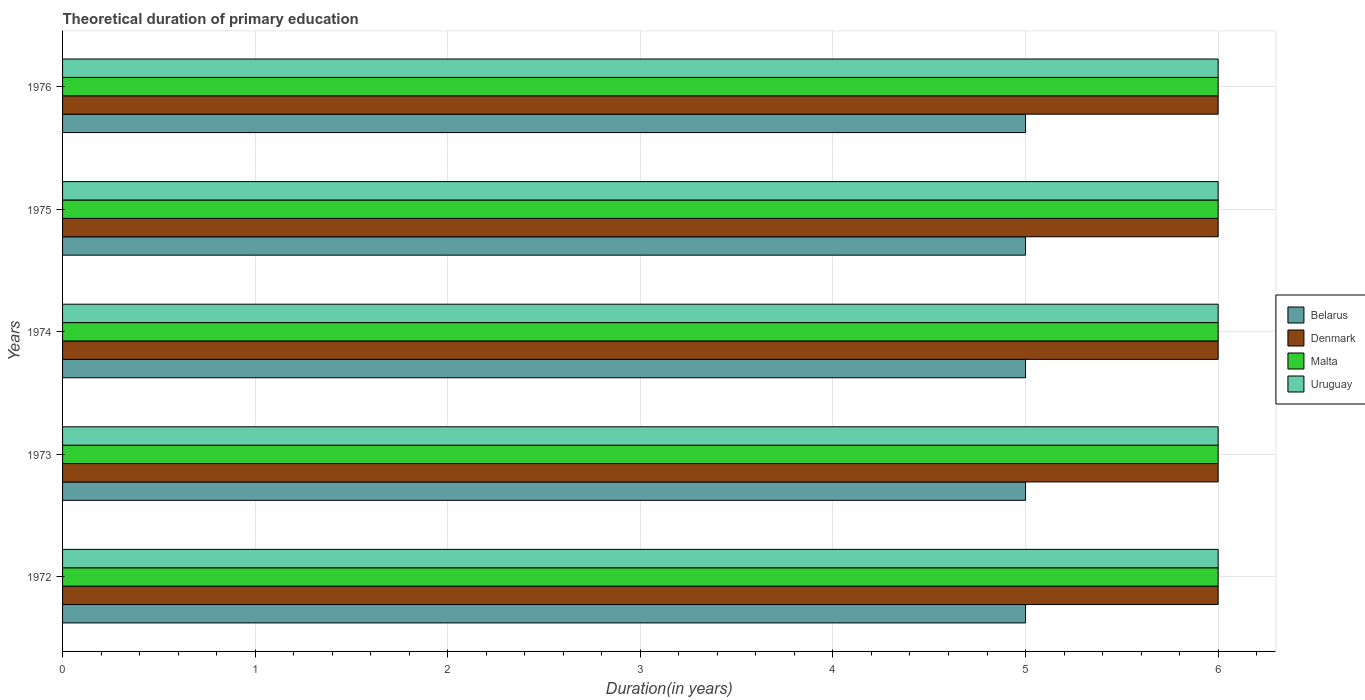How many bars are there on the 5th tick from the bottom?
Your response must be concise. 4. What is the label of the 3rd group of bars from the top?
Provide a short and direct response. 1974. In how many cases, is the number of bars for a given year not equal to the number of legend labels?
Offer a terse response. 0. What is the total theoretical duration of primary education in Belarus in 1975?
Provide a succinct answer. 5. Across all years, what is the minimum total theoretical duration of primary education in Denmark?
Your response must be concise. 6. What is the total total theoretical duration of primary education in Malta in the graph?
Your response must be concise. 30. What is the difference between the total theoretical duration of primary education in Belarus in 1973 and that in 1974?
Your answer should be compact. 0. In the year 1975, what is the difference between the total theoretical duration of primary education in Belarus and total theoretical duration of primary education in Denmark?
Offer a very short reply. -1. In how many years, is the total theoretical duration of primary education in Denmark greater than 2.4 years?
Provide a short and direct response. 5. What is the ratio of the total theoretical duration of primary education in Denmark in 1974 to that in 1975?
Make the answer very short. 1. In how many years, is the total theoretical duration of primary education in Uruguay greater than the average total theoretical duration of primary education in Uruguay taken over all years?
Your answer should be very brief. 0. Is the sum of the total theoretical duration of primary education in Belarus in 1974 and 1976 greater than the maximum total theoretical duration of primary education in Malta across all years?
Ensure brevity in your answer.  Yes. Is it the case that in every year, the sum of the total theoretical duration of primary education in Malta and total theoretical duration of primary education in Uruguay is greater than the sum of total theoretical duration of primary education in Belarus and total theoretical duration of primary education in Denmark?
Provide a succinct answer. No. What does the 1st bar from the top in 1976 represents?
Make the answer very short. Uruguay. What does the 4th bar from the bottom in 1973 represents?
Keep it short and to the point. Uruguay. Is it the case that in every year, the sum of the total theoretical duration of primary education in Uruguay and total theoretical duration of primary education in Belarus is greater than the total theoretical duration of primary education in Denmark?
Give a very brief answer. Yes. How many bars are there?
Keep it short and to the point. 20. How many years are there in the graph?
Keep it short and to the point. 5. What is the difference between two consecutive major ticks on the X-axis?
Offer a very short reply. 1. Does the graph contain any zero values?
Provide a short and direct response. No. Where does the legend appear in the graph?
Give a very brief answer. Center right. What is the title of the graph?
Provide a short and direct response. Theoretical duration of primary education. What is the label or title of the X-axis?
Your answer should be very brief. Duration(in years). What is the label or title of the Y-axis?
Provide a short and direct response. Years. What is the Duration(in years) in Belarus in 1972?
Offer a terse response. 5. What is the Duration(in years) of Malta in 1972?
Offer a very short reply. 6. What is the Duration(in years) of Uruguay in 1972?
Your answer should be very brief. 6. What is the Duration(in years) of Belarus in 1973?
Your response must be concise. 5. What is the Duration(in years) of Denmark in 1973?
Give a very brief answer. 6. What is the Duration(in years) in Malta in 1973?
Give a very brief answer. 6. What is the Duration(in years) of Uruguay in 1973?
Ensure brevity in your answer.  6. What is the Duration(in years) in Belarus in 1974?
Offer a very short reply. 5. What is the Duration(in years) in Denmark in 1974?
Your answer should be very brief. 6. What is the Duration(in years) in Belarus in 1975?
Your response must be concise. 5. What is the Duration(in years) in Malta in 1975?
Offer a very short reply. 6. What is the Duration(in years) in Belarus in 1976?
Offer a terse response. 5. What is the Duration(in years) of Denmark in 1976?
Make the answer very short. 6. What is the Duration(in years) in Malta in 1976?
Ensure brevity in your answer.  6. What is the Duration(in years) of Uruguay in 1976?
Your answer should be compact. 6. Across all years, what is the maximum Duration(in years) in Denmark?
Your answer should be compact. 6. Across all years, what is the maximum Duration(in years) in Malta?
Your answer should be very brief. 6. Across all years, what is the minimum Duration(in years) of Malta?
Your response must be concise. 6. Across all years, what is the minimum Duration(in years) of Uruguay?
Provide a succinct answer. 6. What is the total Duration(in years) of Belarus in the graph?
Provide a short and direct response. 25. What is the total Duration(in years) in Denmark in the graph?
Your answer should be compact. 30. What is the total Duration(in years) of Malta in the graph?
Give a very brief answer. 30. What is the total Duration(in years) in Uruguay in the graph?
Give a very brief answer. 30. What is the difference between the Duration(in years) in Denmark in 1972 and that in 1973?
Provide a short and direct response. 0. What is the difference between the Duration(in years) of Uruguay in 1972 and that in 1973?
Keep it short and to the point. 0. What is the difference between the Duration(in years) of Malta in 1972 and that in 1974?
Your answer should be compact. 0. What is the difference between the Duration(in years) of Malta in 1972 and that in 1975?
Offer a very short reply. 0. What is the difference between the Duration(in years) in Uruguay in 1972 and that in 1975?
Your answer should be very brief. 0. What is the difference between the Duration(in years) in Denmark in 1972 and that in 1976?
Give a very brief answer. 0. What is the difference between the Duration(in years) in Malta in 1972 and that in 1976?
Offer a terse response. 0. What is the difference between the Duration(in years) in Uruguay in 1972 and that in 1976?
Your response must be concise. 0. What is the difference between the Duration(in years) in Belarus in 1973 and that in 1974?
Offer a terse response. 0. What is the difference between the Duration(in years) of Denmark in 1973 and that in 1974?
Keep it short and to the point. 0. What is the difference between the Duration(in years) in Malta in 1973 and that in 1974?
Your answer should be very brief. 0. What is the difference between the Duration(in years) of Belarus in 1973 and that in 1975?
Offer a terse response. 0. What is the difference between the Duration(in years) of Malta in 1973 and that in 1975?
Provide a succinct answer. 0. What is the difference between the Duration(in years) of Uruguay in 1973 and that in 1975?
Make the answer very short. 0. What is the difference between the Duration(in years) of Belarus in 1973 and that in 1976?
Offer a terse response. 0. What is the difference between the Duration(in years) of Denmark in 1973 and that in 1976?
Your response must be concise. 0. What is the difference between the Duration(in years) in Malta in 1973 and that in 1976?
Provide a short and direct response. 0. What is the difference between the Duration(in years) in Uruguay in 1973 and that in 1976?
Keep it short and to the point. 0. What is the difference between the Duration(in years) of Denmark in 1974 and that in 1975?
Offer a very short reply. 0. What is the difference between the Duration(in years) of Uruguay in 1974 and that in 1975?
Offer a terse response. 0. What is the difference between the Duration(in years) of Denmark in 1974 and that in 1976?
Offer a very short reply. 0. What is the difference between the Duration(in years) of Malta in 1974 and that in 1976?
Make the answer very short. 0. What is the difference between the Duration(in years) in Uruguay in 1974 and that in 1976?
Provide a succinct answer. 0. What is the difference between the Duration(in years) in Belarus in 1975 and that in 1976?
Provide a succinct answer. 0. What is the difference between the Duration(in years) in Malta in 1975 and that in 1976?
Offer a terse response. 0. What is the difference between the Duration(in years) in Belarus in 1972 and the Duration(in years) in Uruguay in 1973?
Make the answer very short. -1. What is the difference between the Duration(in years) of Denmark in 1972 and the Duration(in years) of Malta in 1973?
Keep it short and to the point. 0. What is the difference between the Duration(in years) of Belarus in 1972 and the Duration(in years) of Denmark in 1974?
Your answer should be very brief. -1. What is the difference between the Duration(in years) of Belarus in 1972 and the Duration(in years) of Malta in 1974?
Make the answer very short. -1. What is the difference between the Duration(in years) of Belarus in 1972 and the Duration(in years) of Uruguay in 1974?
Your answer should be compact. -1. What is the difference between the Duration(in years) of Denmark in 1972 and the Duration(in years) of Uruguay in 1974?
Give a very brief answer. 0. What is the difference between the Duration(in years) in Belarus in 1972 and the Duration(in years) in Uruguay in 1975?
Keep it short and to the point. -1. What is the difference between the Duration(in years) in Denmark in 1972 and the Duration(in years) in Malta in 1975?
Offer a terse response. 0. What is the difference between the Duration(in years) in Denmark in 1972 and the Duration(in years) in Uruguay in 1975?
Provide a short and direct response. 0. What is the difference between the Duration(in years) in Belarus in 1972 and the Duration(in years) in Malta in 1976?
Offer a very short reply. -1. What is the difference between the Duration(in years) of Belarus in 1972 and the Duration(in years) of Uruguay in 1976?
Keep it short and to the point. -1. What is the difference between the Duration(in years) in Denmark in 1972 and the Duration(in years) in Malta in 1976?
Your answer should be very brief. 0. What is the difference between the Duration(in years) of Denmark in 1972 and the Duration(in years) of Uruguay in 1976?
Ensure brevity in your answer.  0. What is the difference between the Duration(in years) of Malta in 1972 and the Duration(in years) of Uruguay in 1976?
Provide a succinct answer. 0. What is the difference between the Duration(in years) of Belarus in 1973 and the Duration(in years) of Denmark in 1974?
Your answer should be compact. -1. What is the difference between the Duration(in years) of Belarus in 1973 and the Duration(in years) of Malta in 1974?
Your answer should be very brief. -1. What is the difference between the Duration(in years) in Belarus in 1973 and the Duration(in years) in Uruguay in 1974?
Your response must be concise. -1. What is the difference between the Duration(in years) in Denmark in 1973 and the Duration(in years) in Uruguay in 1974?
Provide a short and direct response. 0. What is the difference between the Duration(in years) of Belarus in 1973 and the Duration(in years) of Denmark in 1975?
Your answer should be compact. -1. What is the difference between the Duration(in years) in Belarus in 1973 and the Duration(in years) in Malta in 1975?
Provide a short and direct response. -1. What is the difference between the Duration(in years) in Denmark in 1973 and the Duration(in years) in Malta in 1975?
Give a very brief answer. 0. What is the difference between the Duration(in years) of Denmark in 1973 and the Duration(in years) of Uruguay in 1975?
Ensure brevity in your answer.  0. What is the difference between the Duration(in years) of Malta in 1973 and the Duration(in years) of Uruguay in 1975?
Your response must be concise. 0. What is the difference between the Duration(in years) in Belarus in 1973 and the Duration(in years) in Denmark in 1976?
Offer a very short reply. -1. What is the difference between the Duration(in years) in Denmark in 1973 and the Duration(in years) in Uruguay in 1976?
Offer a very short reply. 0. What is the difference between the Duration(in years) of Malta in 1973 and the Duration(in years) of Uruguay in 1976?
Your answer should be compact. 0. What is the difference between the Duration(in years) in Belarus in 1974 and the Duration(in years) in Malta in 1975?
Give a very brief answer. -1. What is the difference between the Duration(in years) in Belarus in 1974 and the Duration(in years) in Uruguay in 1975?
Provide a succinct answer. -1. What is the difference between the Duration(in years) of Denmark in 1974 and the Duration(in years) of Uruguay in 1975?
Make the answer very short. 0. What is the difference between the Duration(in years) of Belarus in 1974 and the Duration(in years) of Denmark in 1976?
Ensure brevity in your answer.  -1. What is the difference between the Duration(in years) in Belarus in 1974 and the Duration(in years) in Uruguay in 1976?
Offer a very short reply. -1. What is the difference between the Duration(in years) of Denmark in 1974 and the Duration(in years) of Uruguay in 1976?
Make the answer very short. 0. What is the difference between the Duration(in years) of Denmark in 1975 and the Duration(in years) of Malta in 1976?
Ensure brevity in your answer.  0. What is the difference between the Duration(in years) of Denmark in 1975 and the Duration(in years) of Uruguay in 1976?
Your answer should be very brief. 0. What is the difference between the Duration(in years) of Malta in 1975 and the Duration(in years) of Uruguay in 1976?
Give a very brief answer. 0. What is the average Duration(in years) in Belarus per year?
Your answer should be compact. 5. What is the average Duration(in years) of Uruguay per year?
Give a very brief answer. 6. In the year 1972, what is the difference between the Duration(in years) in Belarus and Duration(in years) in Denmark?
Make the answer very short. -1. In the year 1972, what is the difference between the Duration(in years) of Belarus and Duration(in years) of Malta?
Your answer should be compact. -1. In the year 1972, what is the difference between the Duration(in years) of Malta and Duration(in years) of Uruguay?
Keep it short and to the point. 0. In the year 1973, what is the difference between the Duration(in years) of Belarus and Duration(in years) of Denmark?
Make the answer very short. -1. In the year 1973, what is the difference between the Duration(in years) of Denmark and Duration(in years) of Uruguay?
Your answer should be very brief. 0. In the year 1974, what is the difference between the Duration(in years) in Belarus and Duration(in years) in Denmark?
Ensure brevity in your answer.  -1. In the year 1975, what is the difference between the Duration(in years) in Belarus and Duration(in years) in Denmark?
Your answer should be compact. -1. In the year 1975, what is the difference between the Duration(in years) in Belarus and Duration(in years) in Uruguay?
Provide a succinct answer. -1. In the year 1976, what is the difference between the Duration(in years) in Belarus and Duration(in years) in Malta?
Give a very brief answer. -1. In the year 1976, what is the difference between the Duration(in years) in Denmark and Duration(in years) in Malta?
Your answer should be compact. 0. In the year 1976, what is the difference between the Duration(in years) of Malta and Duration(in years) of Uruguay?
Offer a terse response. 0. What is the ratio of the Duration(in years) of Uruguay in 1972 to that in 1973?
Give a very brief answer. 1. What is the ratio of the Duration(in years) of Belarus in 1972 to that in 1974?
Keep it short and to the point. 1. What is the ratio of the Duration(in years) in Denmark in 1972 to that in 1974?
Provide a short and direct response. 1. What is the ratio of the Duration(in years) in Malta in 1972 to that in 1974?
Your response must be concise. 1. What is the ratio of the Duration(in years) of Uruguay in 1972 to that in 1974?
Keep it short and to the point. 1. What is the ratio of the Duration(in years) of Belarus in 1972 to that in 1975?
Provide a short and direct response. 1. What is the ratio of the Duration(in years) in Malta in 1972 to that in 1975?
Offer a terse response. 1. What is the ratio of the Duration(in years) of Belarus in 1972 to that in 1976?
Your answer should be very brief. 1. What is the ratio of the Duration(in years) of Denmark in 1972 to that in 1976?
Keep it short and to the point. 1. What is the ratio of the Duration(in years) in Malta in 1972 to that in 1976?
Offer a very short reply. 1. What is the ratio of the Duration(in years) in Uruguay in 1972 to that in 1976?
Give a very brief answer. 1. What is the ratio of the Duration(in years) in Denmark in 1973 to that in 1975?
Your answer should be compact. 1. What is the ratio of the Duration(in years) of Belarus in 1973 to that in 1976?
Offer a very short reply. 1. What is the ratio of the Duration(in years) in Denmark in 1973 to that in 1976?
Provide a succinct answer. 1. What is the ratio of the Duration(in years) in Belarus in 1974 to that in 1975?
Ensure brevity in your answer.  1. What is the ratio of the Duration(in years) in Denmark in 1974 to that in 1975?
Offer a very short reply. 1. What is the ratio of the Duration(in years) of Malta in 1974 to that in 1975?
Provide a succinct answer. 1. What is the ratio of the Duration(in years) in Uruguay in 1974 to that in 1975?
Provide a short and direct response. 1. What is the ratio of the Duration(in years) in Uruguay in 1974 to that in 1976?
Keep it short and to the point. 1. What is the ratio of the Duration(in years) of Belarus in 1975 to that in 1976?
Provide a succinct answer. 1. What is the ratio of the Duration(in years) of Uruguay in 1975 to that in 1976?
Provide a short and direct response. 1. What is the difference between the highest and the second highest Duration(in years) of Denmark?
Offer a terse response. 0. What is the difference between the highest and the second highest Duration(in years) of Malta?
Keep it short and to the point. 0. What is the difference between the highest and the second highest Duration(in years) in Uruguay?
Offer a very short reply. 0. What is the difference between the highest and the lowest Duration(in years) of Malta?
Keep it short and to the point. 0. 